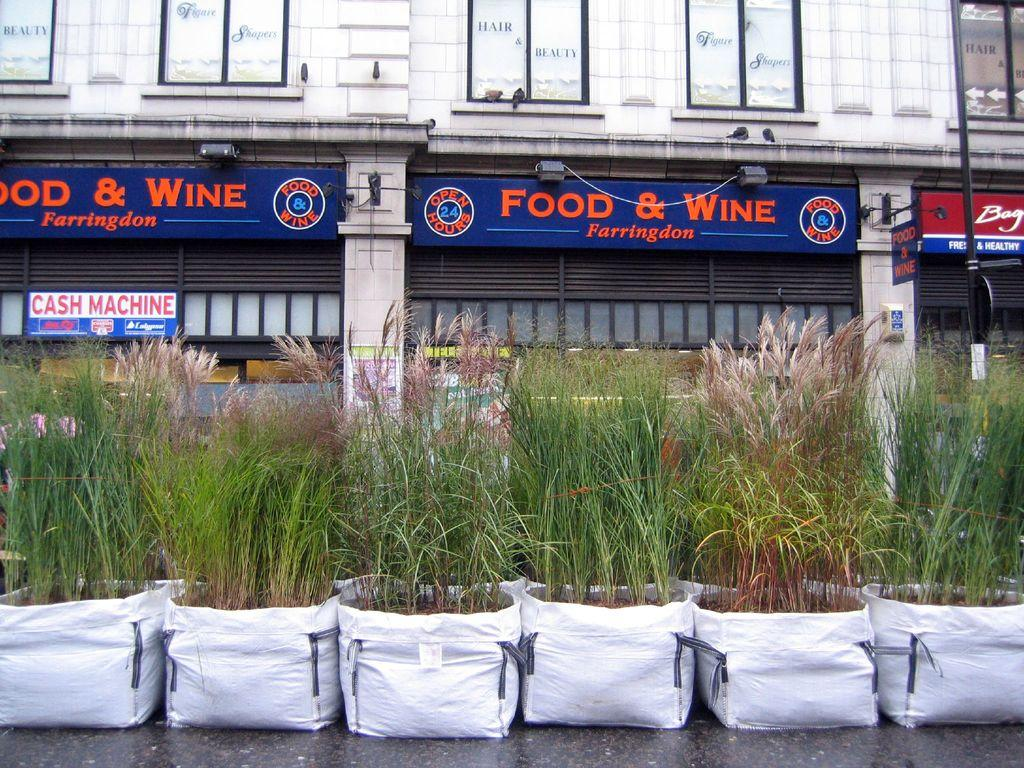What is placed on the white covers in the image? There are plants on the white covers in the image. What can be seen in the background of the image? There is a building in the background of the image. What features of the building are visible? The building has windows, name boards, and pillars. Where is the faucet located in the image? There is no faucet present in the image. What is the condition of the spoon in the image? There is no spoon present in the image. 